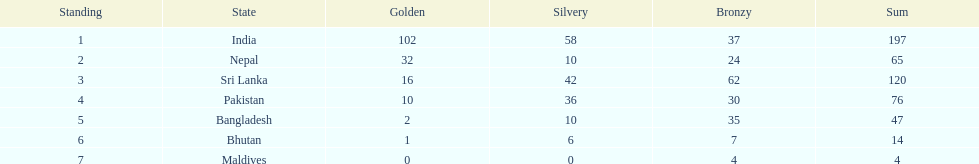How many gold medals were awarded between all 7 nations? 163. 